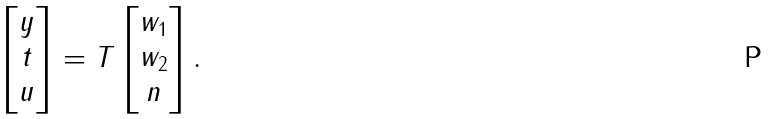<formula> <loc_0><loc_0><loc_500><loc_500>\begin{bmatrix} y \\ t \\ u \end{bmatrix} = T \begin{bmatrix} w _ { 1 } \\ w _ { 2 } \\ n \end{bmatrix} .</formula> 